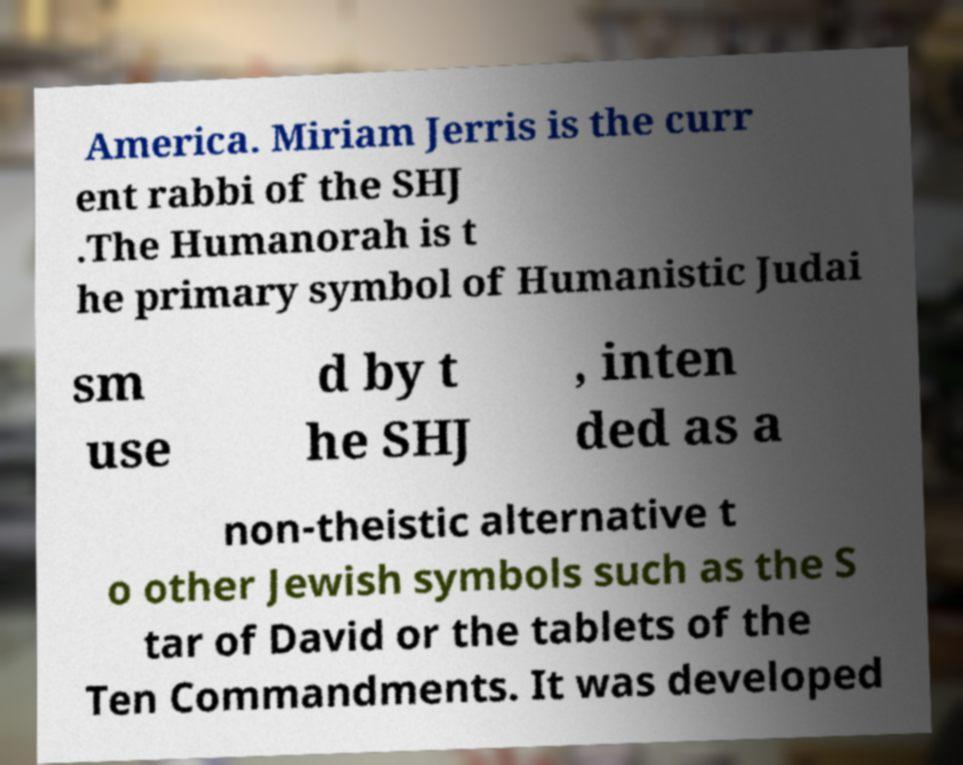There's text embedded in this image that I need extracted. Can you transcribe it verbatim? America. Miriam Jerris is the curr ent rabbi of the SHJ .The Humanorah is t he primary symbol of Humanistic Judai sm use d by t he SHJ , inten ded as a non-theistic alternative t o other Jewish symbols such as the S tar of David or the tablets of the Ten Commandments. It was developed 